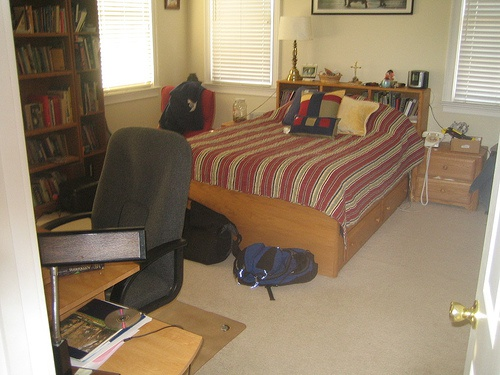Describe the objects in this image and their specific colors. I can see bed in darkgray, gray, and brown tones, chair in darkgray, black, and gray tones, book in darkgray, black, maroon, and gray tones, backpack in darkgray, gray, and black tones, and handbag in darkgray, black, maroon, and gray tones in this image. 